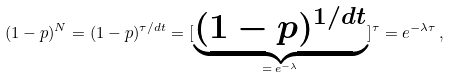<formula> <loc_0><loc_0><loc_500><loc_500>( 1 - p ) ^ { N } = ( 1 - p ) ^ { \tau / d t } = [ \underbrace { ( 1 - p ) ^ { 1 / d t } } _ { = \, e ^ { - \lambda } } ] ^ { \tau } = e ^ { - \lambda \tau } \, ,</formula> 